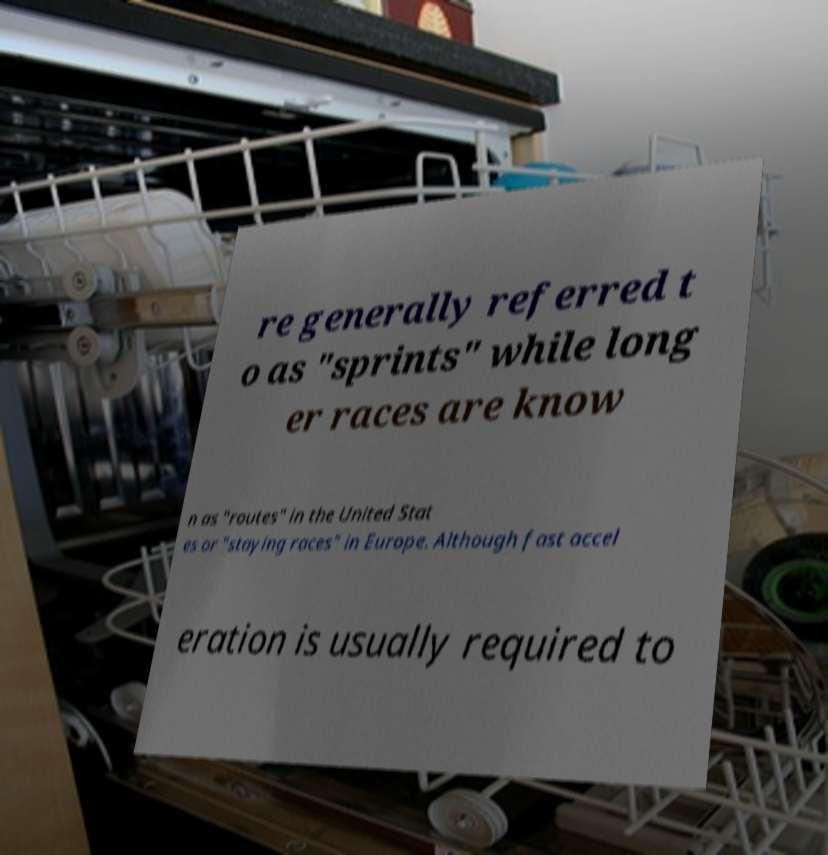Can you read and provide the text displayed in the image?This photo seems to have some interesting text. Can you extract and type it out for me? re generally referred t o as "sprints" while long er races are know n as "routes" in the United Stat es or "staying races" in Europe. Although fast accel eration is usually required to 